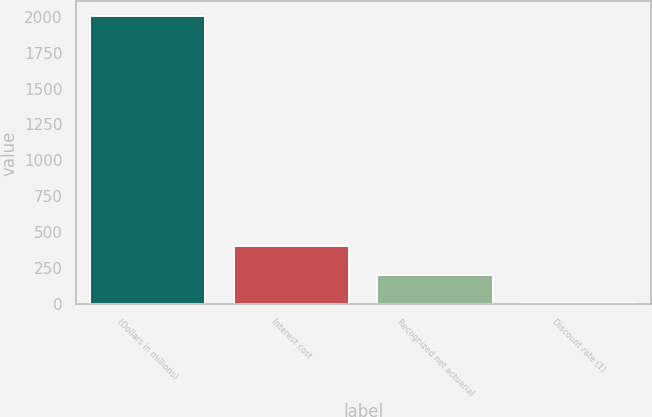Convert chart to OTSL. <chart><loc_0><loc_0><loc_500><loc_500><bar_chart><fcel>(Dollars in millions)<fcel>Interest cost<fcel>Recognized net actuarial<fcel>Discount rate (1)<nl><fcel>2005<fcel>405.61<fcel>205.68<fcel>5.75<nl></chart> 